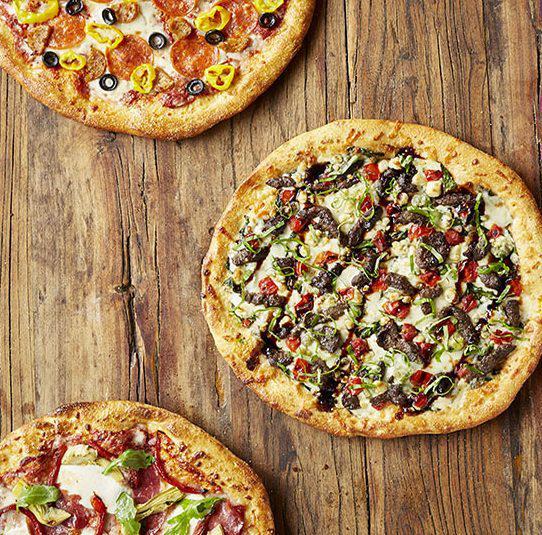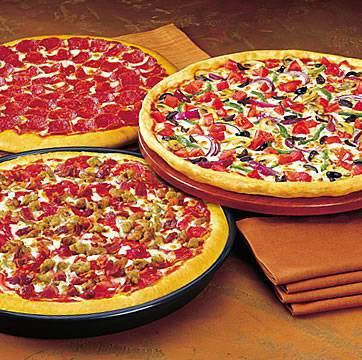The first image is the image on the left, the second image is the image on the right. For the images displayed, is the sentence "The right image shows a slice of pizza lifted upward, with cheese stretching along its side, from a round pie, and the left image includes a whole round pizza." factually correct? Answer yes or no. No. The first image is the image on the left, the second image is the image on the right. Analyze the images presented: Is the assertion "One slice is being lifted off the pizza." valid? Answer yes or no. No. 